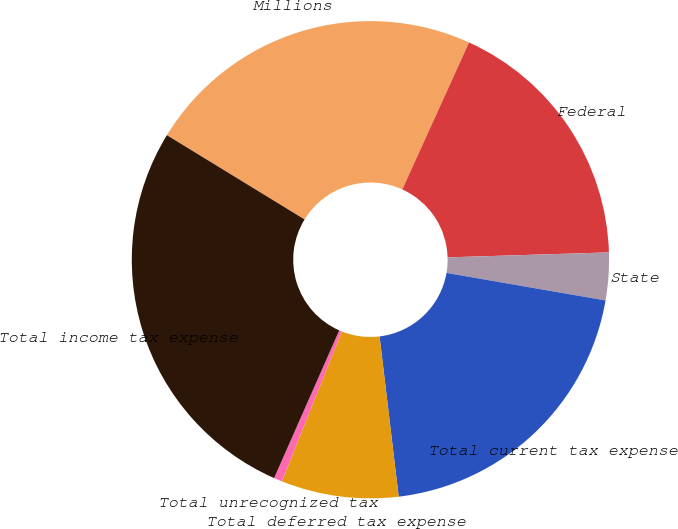Convert chart to OTSL. <chart><loc_0><loc_0><loc_500><loc_500><pie_chart><fcel>Millions<fcel>Federal<fcel>State<fcel>Total current tax expense<fcel>Total deferred tax expense<fcel>Total unrecognized tax<fcel>Total income tax expense<nl><fcel>23.04%<fcel>17.73%<fcel>3.22%<fcel>20.38%<fcel>7.94%<fcel>0.56%<fcel>27.13%<nl></chart> 